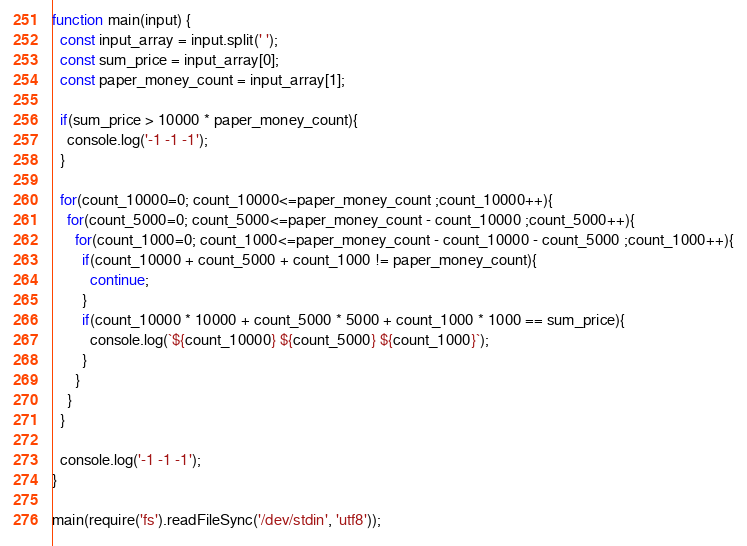Convert code to text. <code><loc_0><loc_0><loc_500><loc_500><_JavaScript_>function main(input) {
  const input_array = input.split(' ');
  const sum_price = input_array[0];
  const paper_money_count = input_array[1];
  
  if(sum_price > 10000 * paper_money_count){
    console.log('-1 -1 -1');
  }

  for(count_10000=0; count_10000<=paper_money_count ;count_10000++){
    for(count_5000=0; count_5000<=paper_money_count - count_10000 ;count_5000++){
      for(count_1000=0; count_1000<=paper_money_count - count_10000 - count_5000 ;count_1000++){
        if(count_10000 + count_5000 + count_1000 != paper_money_count){
          continue;
        }
        if(count_10000 * 10000 + count_5000 * 5000 + count_1000 * 1000 == sum_price){
          console.log(`${count_10000} ${count_5000} ${count_1000}`);
        }
      }
    }
  }

  console.log('-1 -1 -1');
}
 
main(require('fs').readFileSync('/dev/stdin', 'utf8'));
</code> 